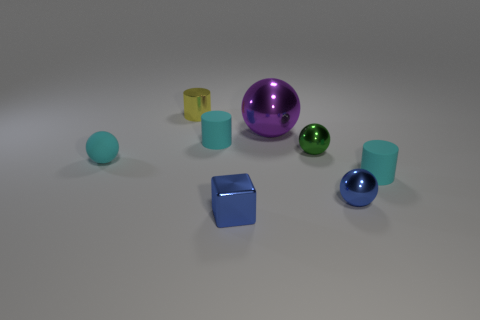What size is the shiny object that is the same color as the shiny cube? The shiny object that shares the same vivid blue color as the shiny cube appears to be a small sphere, considerably smaller in size when compared to the other objects nearby, including the cube itself. 